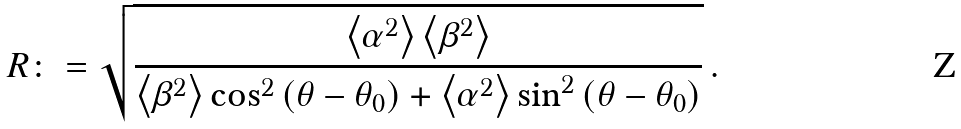<formula> <loc_0><loc_0><loc_500><loc_500>R \colon = \sqrt { \frac { \left < \alpha ^ { 2 } \right > \left < \beta ^ { 2 } \right > } { \left < \beta ^ { 2 } \right > \cos ^ { 2 } \left ( \theta - \theta _ { 0 } \right ) + \left < \alpha ^ { 2 } \right > \sin ^ { 2 } \left ( \theta - \theta _ { 0 } \right ) } } \, .</formula> 